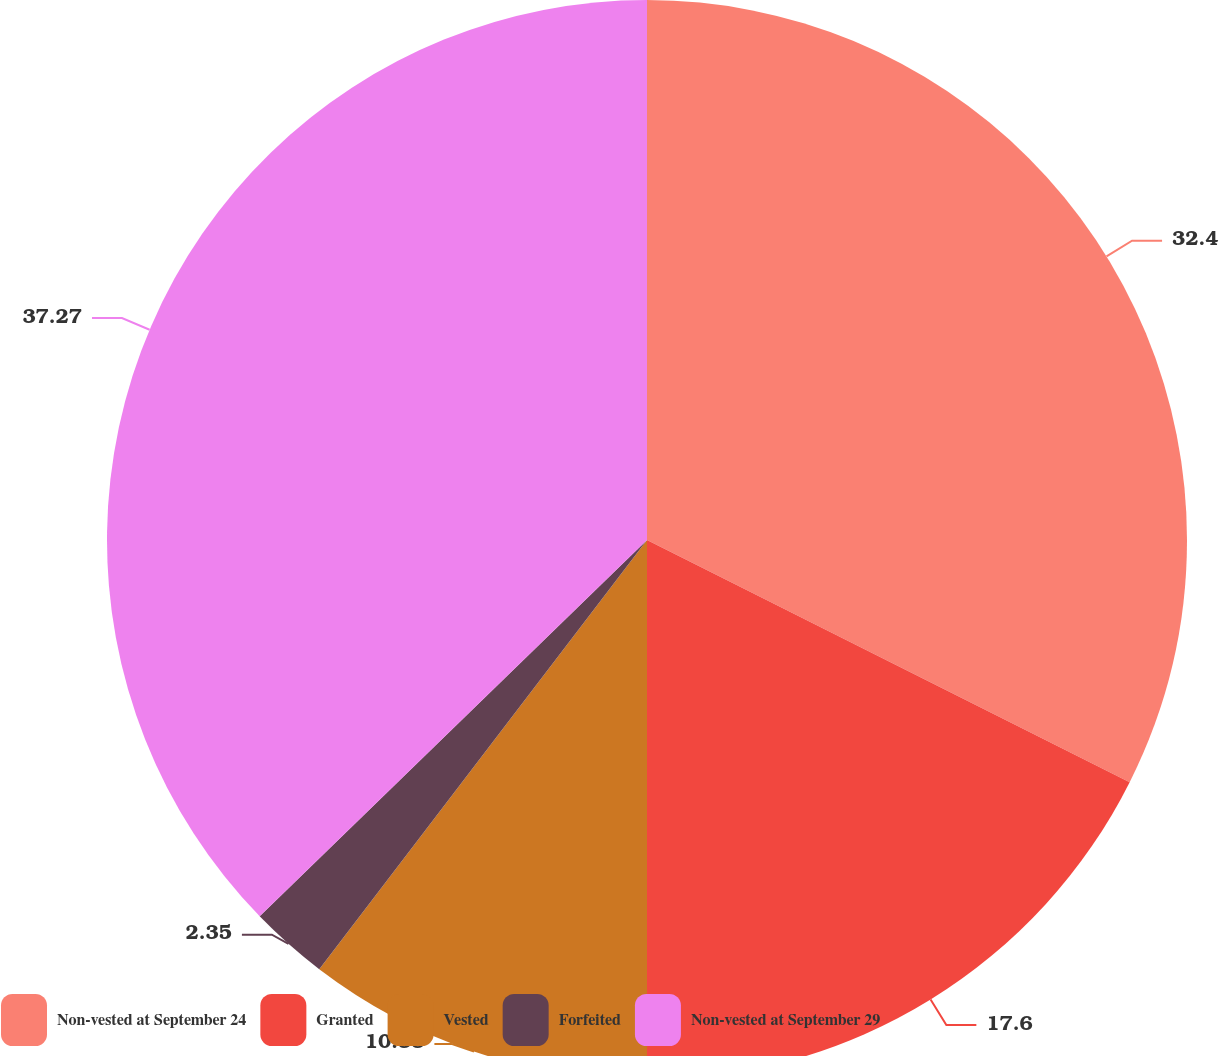<chart> <loc_0><loc_0><loc_500><loc_500><pie_chart><fcel>Non-vested at September 24<fcel>Granted<fcel>Vested<fcel>Forfeited<fcel>Non-vested at September 29<nl><fcel>32.4%<fcel>17.6%<fcel>10.38%<fcel>2.35%<fcel>37.27%<nl></chart> 